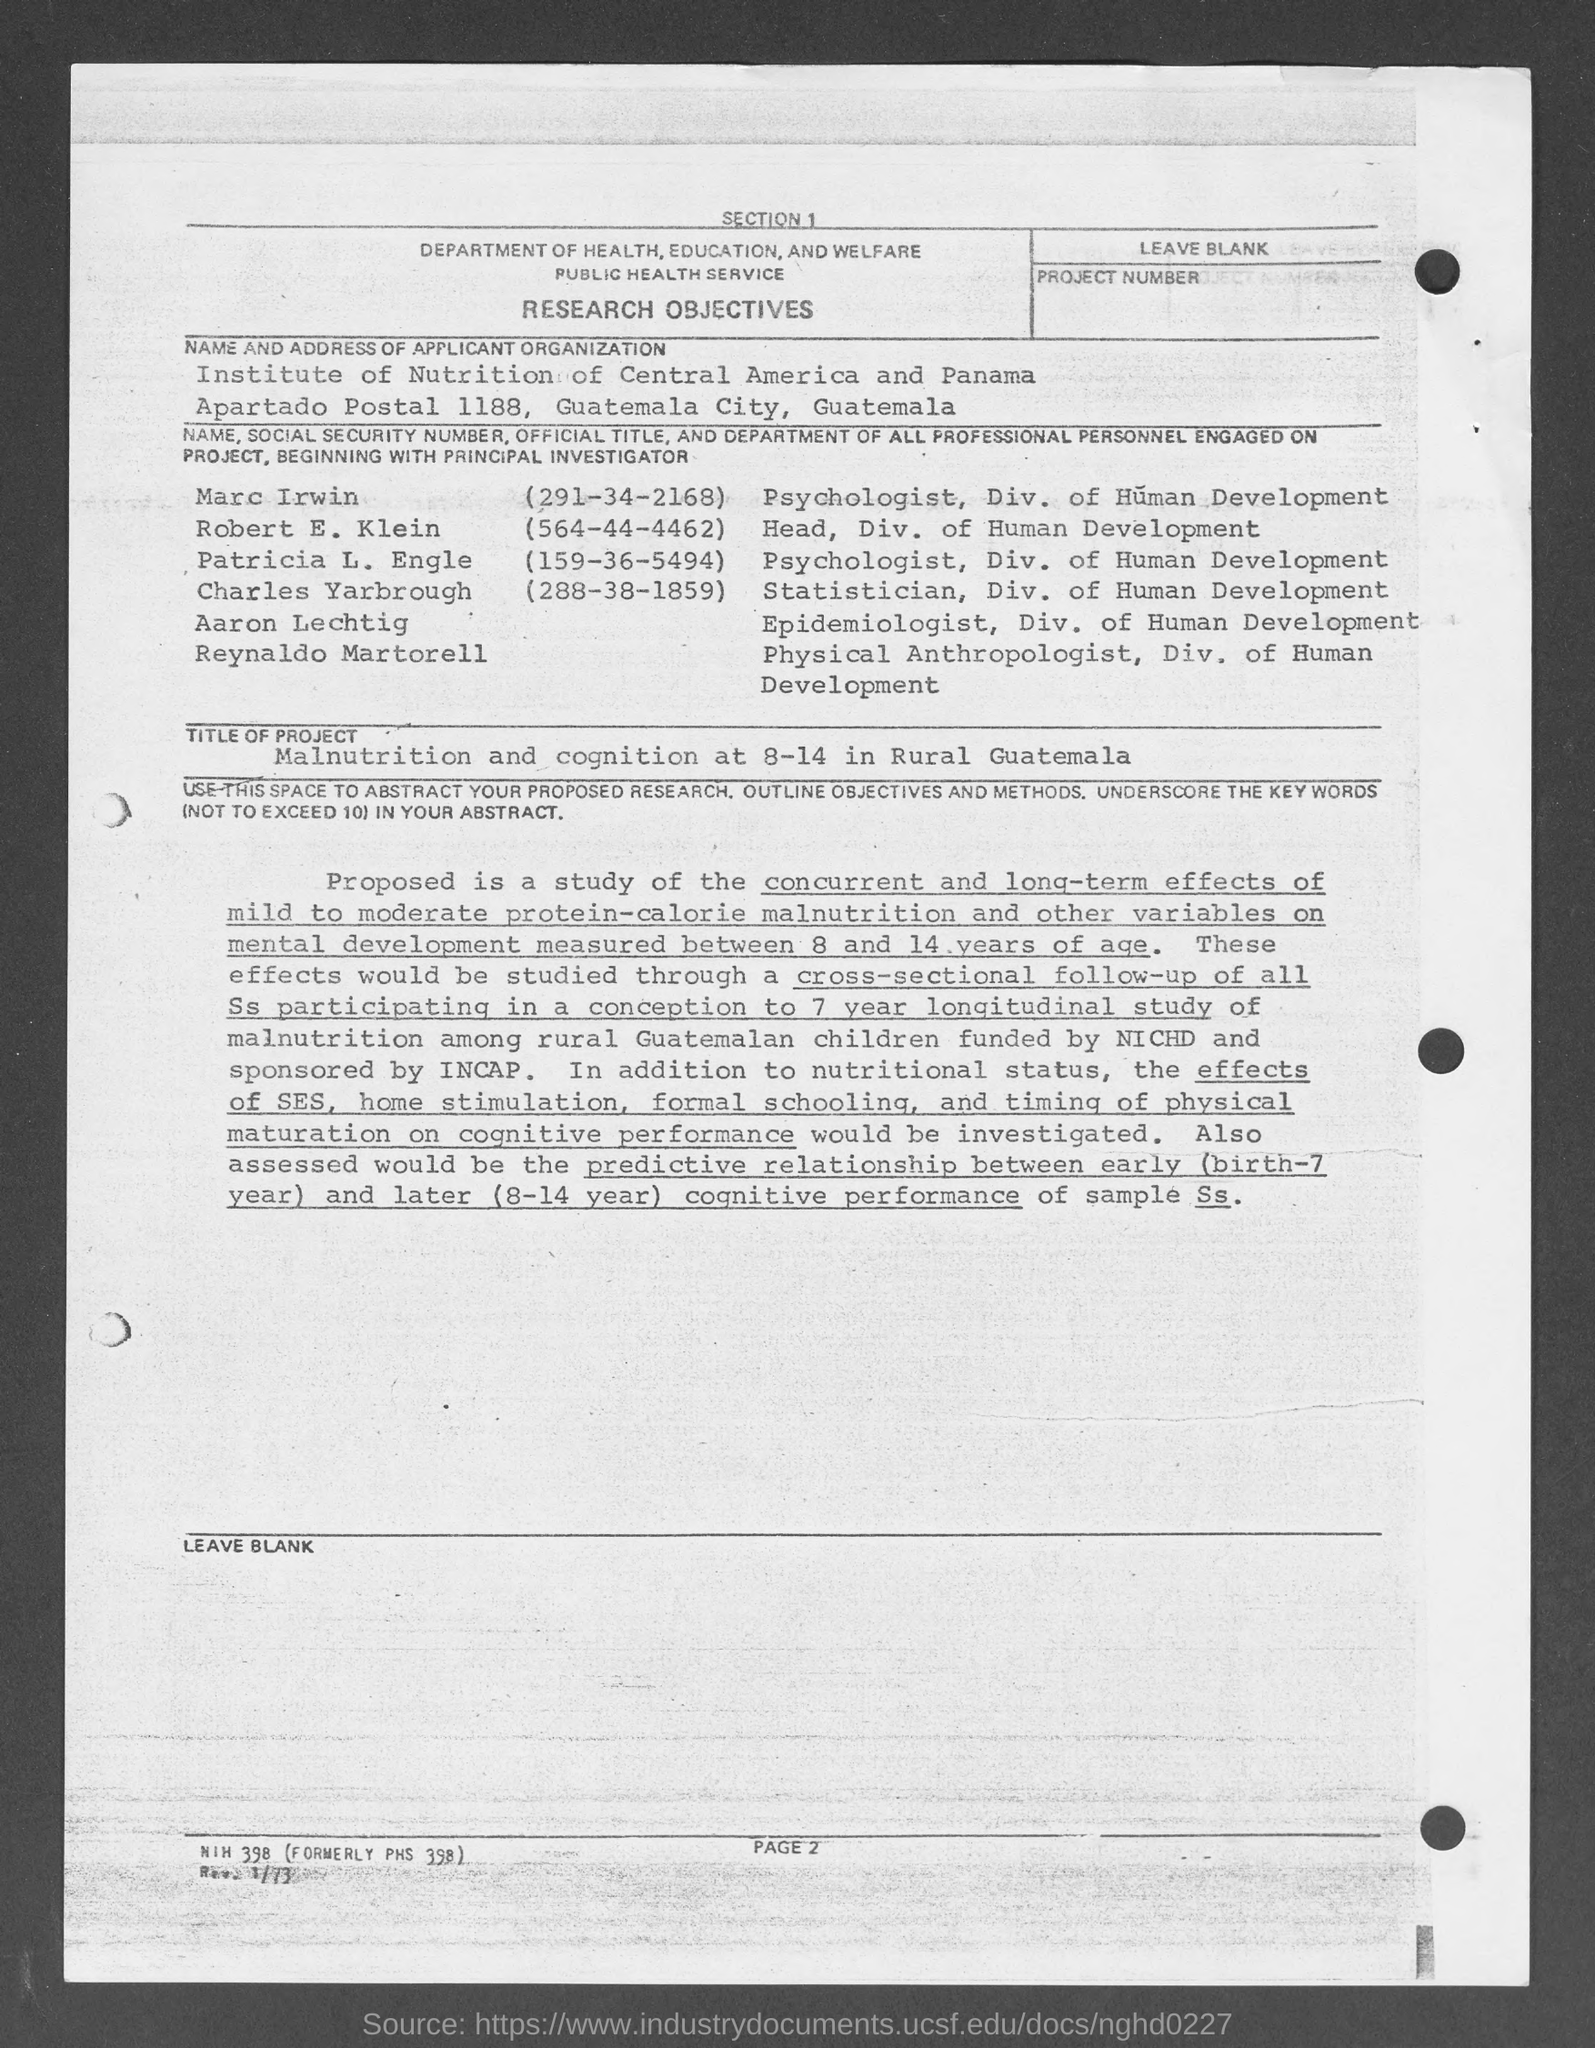What is the Social Security Number of Marc Irwin?
Make the answer very short. (291-34-2168). What is the Social Security Number of Robert E. Klein?
Keep it short and to the point. (564-44-4462). What is the Social Security Number of Patricia L. Engle?
Offer a very short reply. (159-36-5494). What is the Social Security Number of Charles Yarbrough?
Keep it short and to the point. (288-38-1859). 